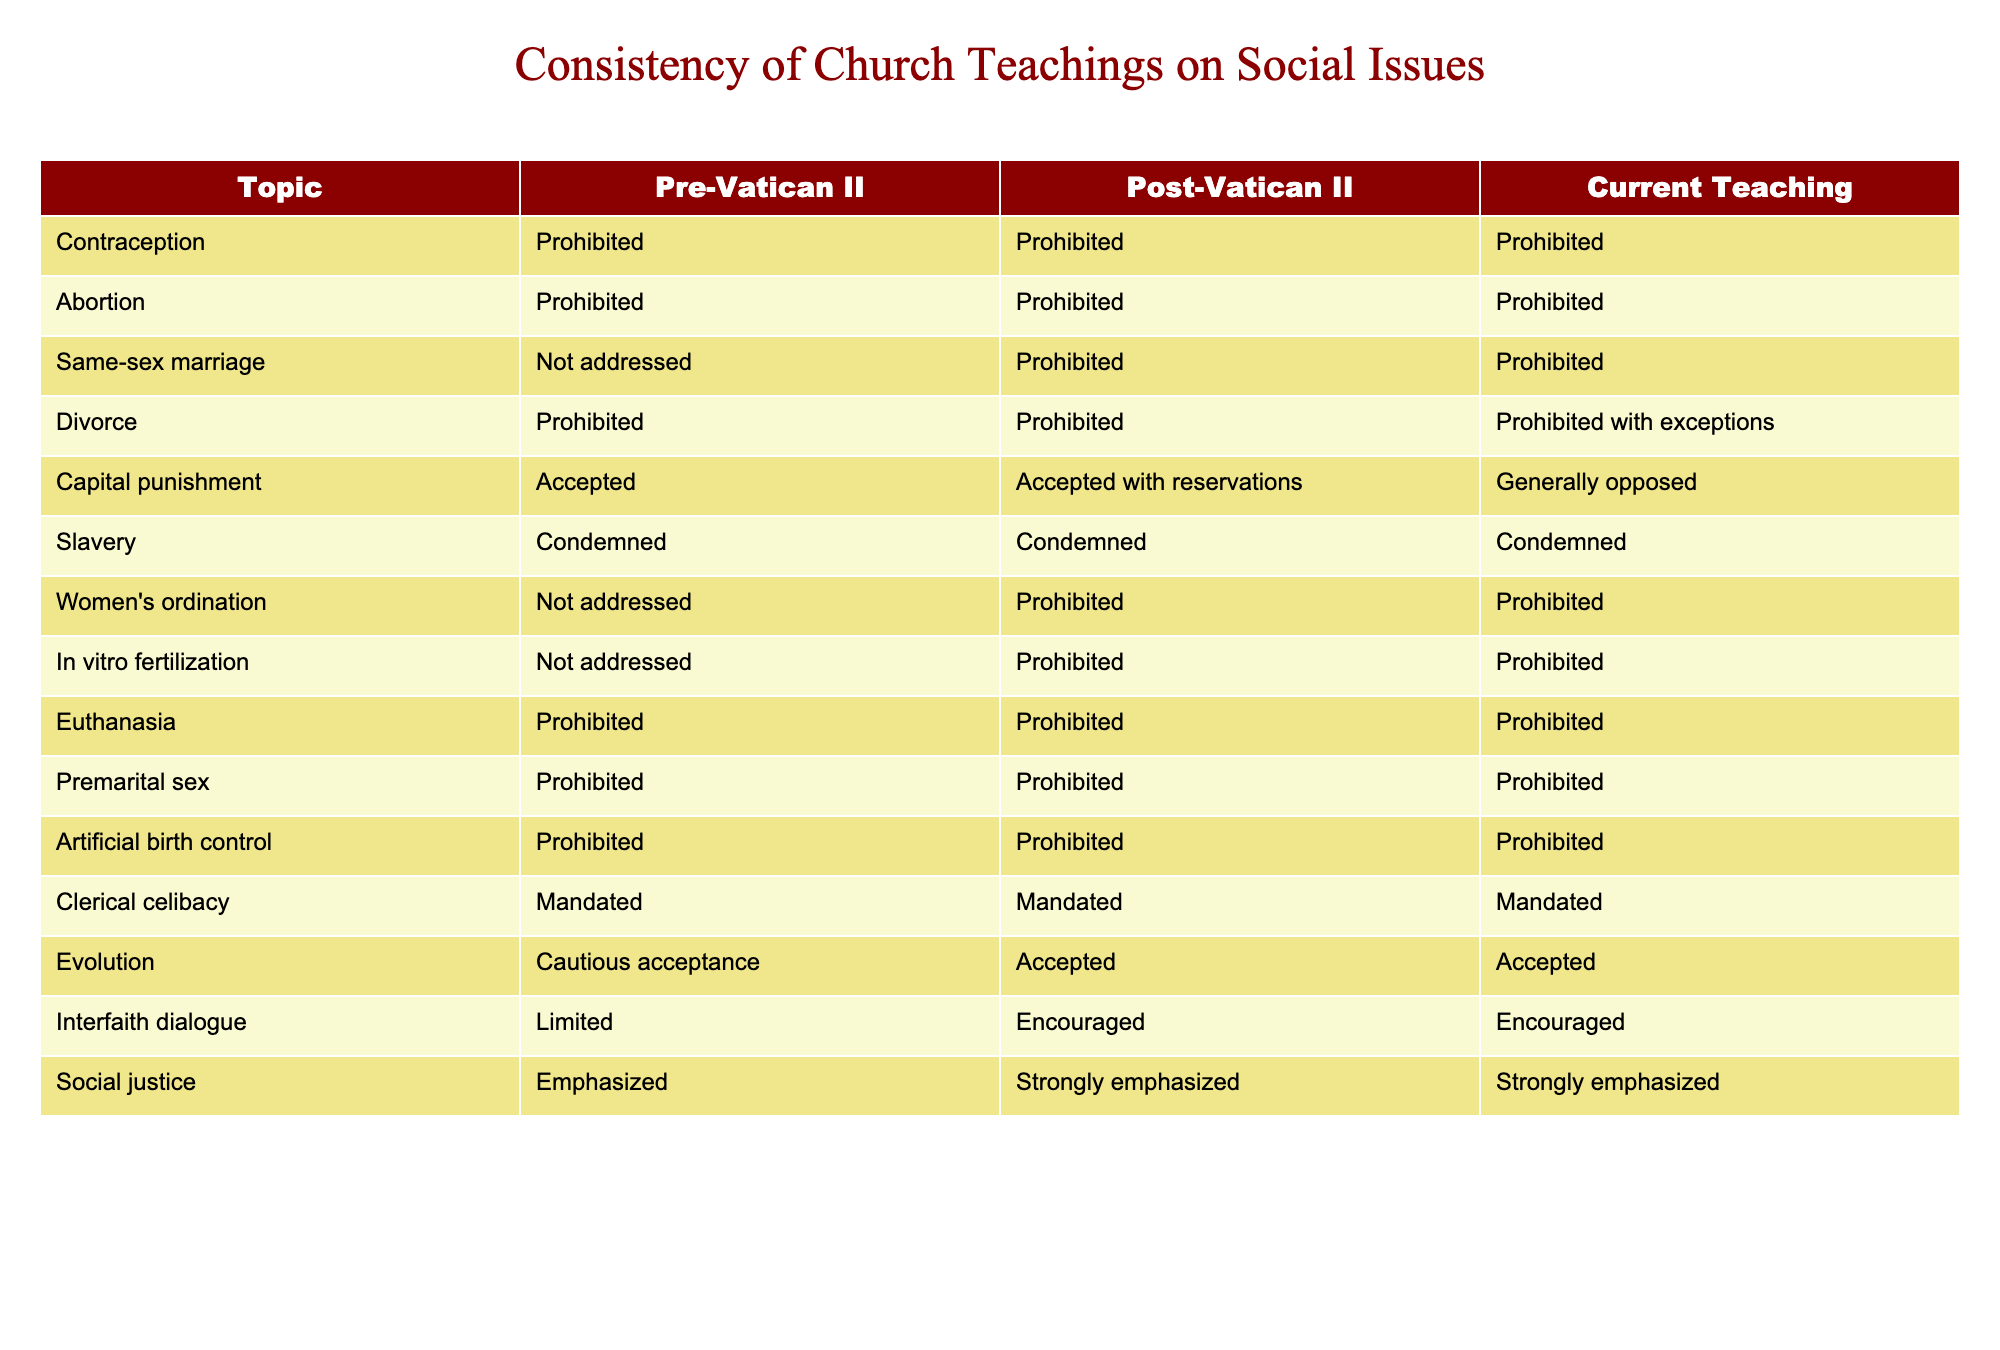What is the Church's teaching on contraception currently? The current teaching on contraception, as listed in the table, is "Prohibited." This information can be found under the "Current Teaching" column corresponding to the topic "Contraception."
Answer: Prohibited Was the teaching on same-sex marriage ever addressed before Vatican II? The table indicates that same-sex marriage was "Not addressed" before Vatican II in the "Pre-Vatican II" column. Therefore, the Church did not provide any official stance on this issue prior to that time.
Answer: Yes How many topics have the same position on social issues before and after Vatican II? By examining the rows for both the "Pre-Vatican II" and "Post-Vatican II" columns, we find that there are six topics where the teachings are identical: Contraception, Abortion, Divorce, Euthanasia, Slavery, and Women's ordination (Not addressed). This gives us a total of six topics where teachings remained unchanged.
Answer: 6 Is the Church's current teaching on divorce the same as it was before Vatican II? The current teaching on divorce, according to the table, states it is "Prohibited with exceptions," whereas before Vatican II it was simply "Prohibited." This indicates a change in the Church's stance on divorce, hence the answer is no.
Answer: No What is the current teaching on capital punishment compared to pre-Vatican II teachings? The current teaching on capital punishment is "Generally opposed," while the pre-Vatican II teaching was "Accepted." This shows a shift in the Church's perspective on this issue over the years, requiring a comparison between the two teachings.
Answer: Different How many social issues are currently taught as "Prohibited"? By counting the entries in the "Current Teaching" column, we can see that there are eight topics classified as "Prohibited": Contraception, Abortion, Same-sex marriage, Euthanasia, Premarital sex, Artificial birth control, Women's ordination, and In vitro fertilization. Thus, the total is eight issues.
Answer: 8 Has the position on interfaith dialogue changed over time? Looking at the columns for "Pre-Vatican II," "Post-Vatican II," and "Current Teaching," we observe that the stance on interfaith dialogue has moved from "Limited" to "Encouraged," indicating a change in the Church's approach towards interfaith interactions over time.
Answer: Yes Is the teaching on evolution consistent across the time periods recorded? The table shows that the teaching on evolution has evolved from "Cautious acceptance" in the pre-Vatican II era to being "Accepted" in both the post-Vatican II and current teachings, which indicates a shift and hence not a consistent stance throughout that time.
Answer: No 